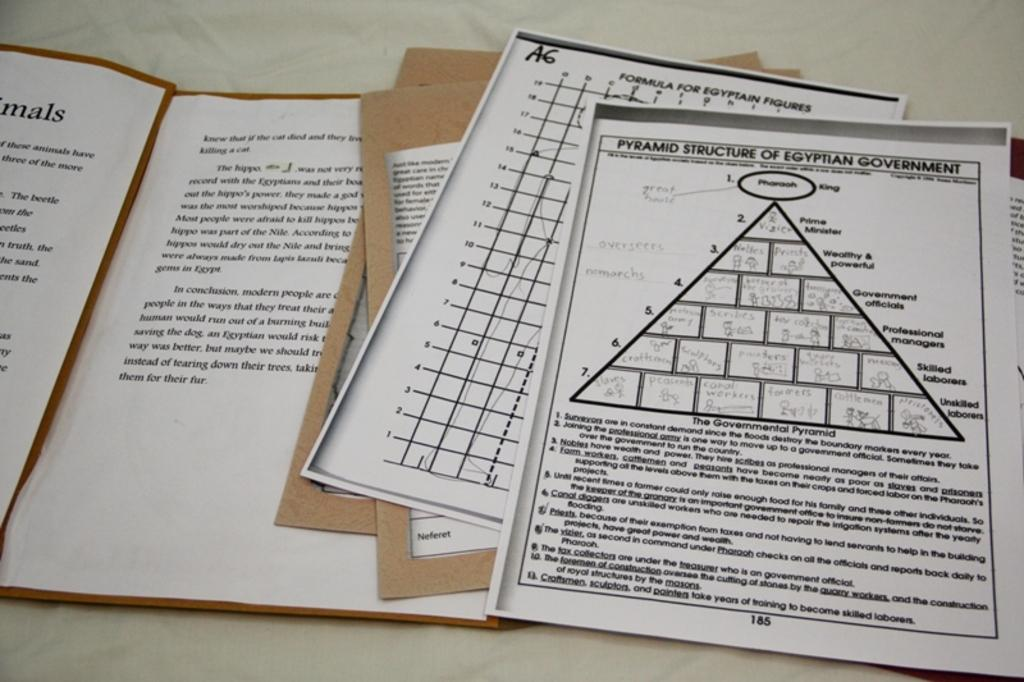<image>
Relay a brief, clear account of the picture shown. the letters mals are on the white paper 